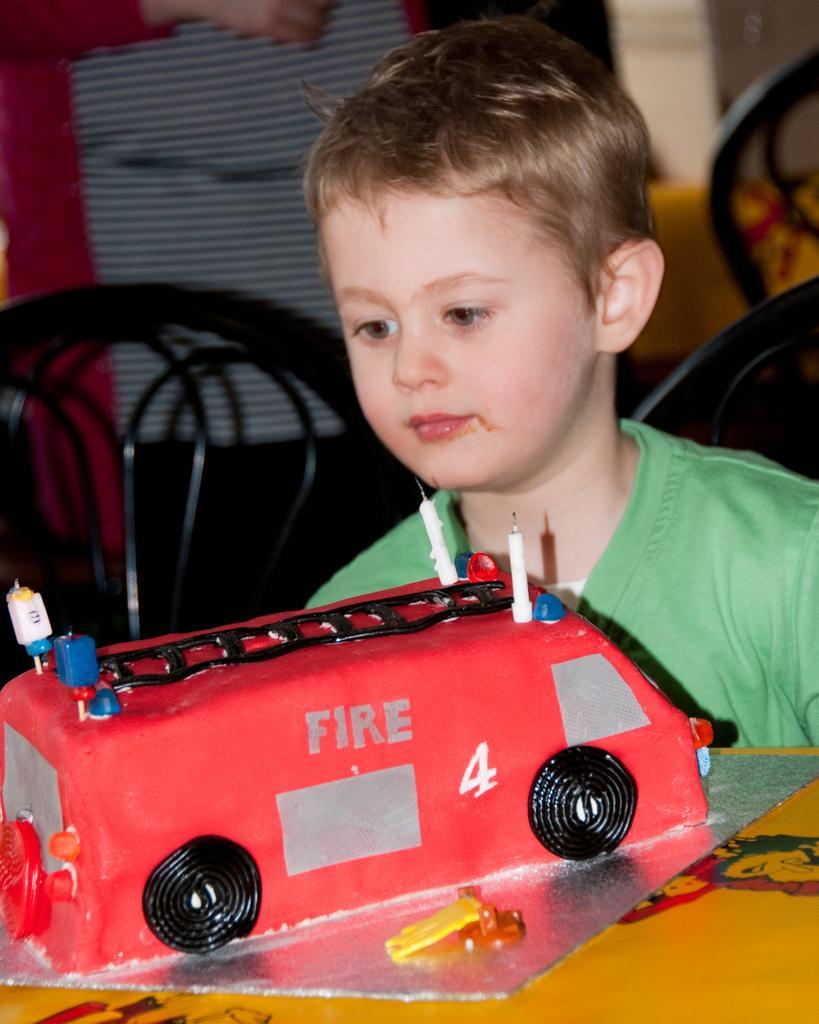How would you summarize this image in a sentence or two? In this image we can see a boy who is wearing green color t-shirt. In front of him cake is there. Behind black color chairs and one person is present. 